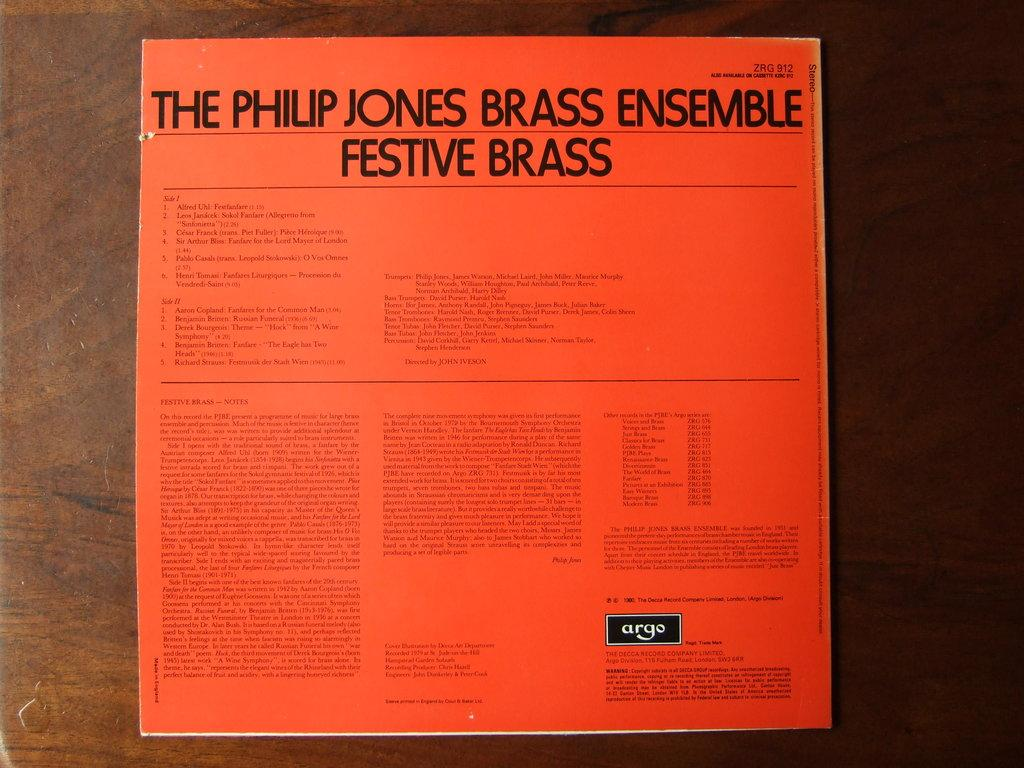<image>
Share a concise interpretation of the image provided. Poster that says The Philip Jones Brass Ensemble Festive Brass. 